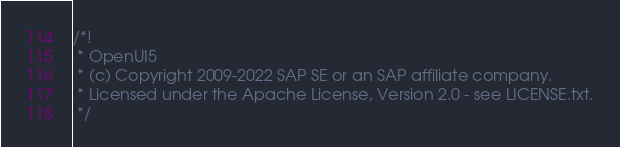Convert code to text. <code><loc_0><loc_0><loc_500><loc_500><_JavaScript_>/*!
 * OpenUI5
 * (c) Copyright 2009-2022 SAP SE or an SAP affiliate company.
 * Licensed under the Apache License, Version 2.0 - see LICENSE.txt.
 */</code> 